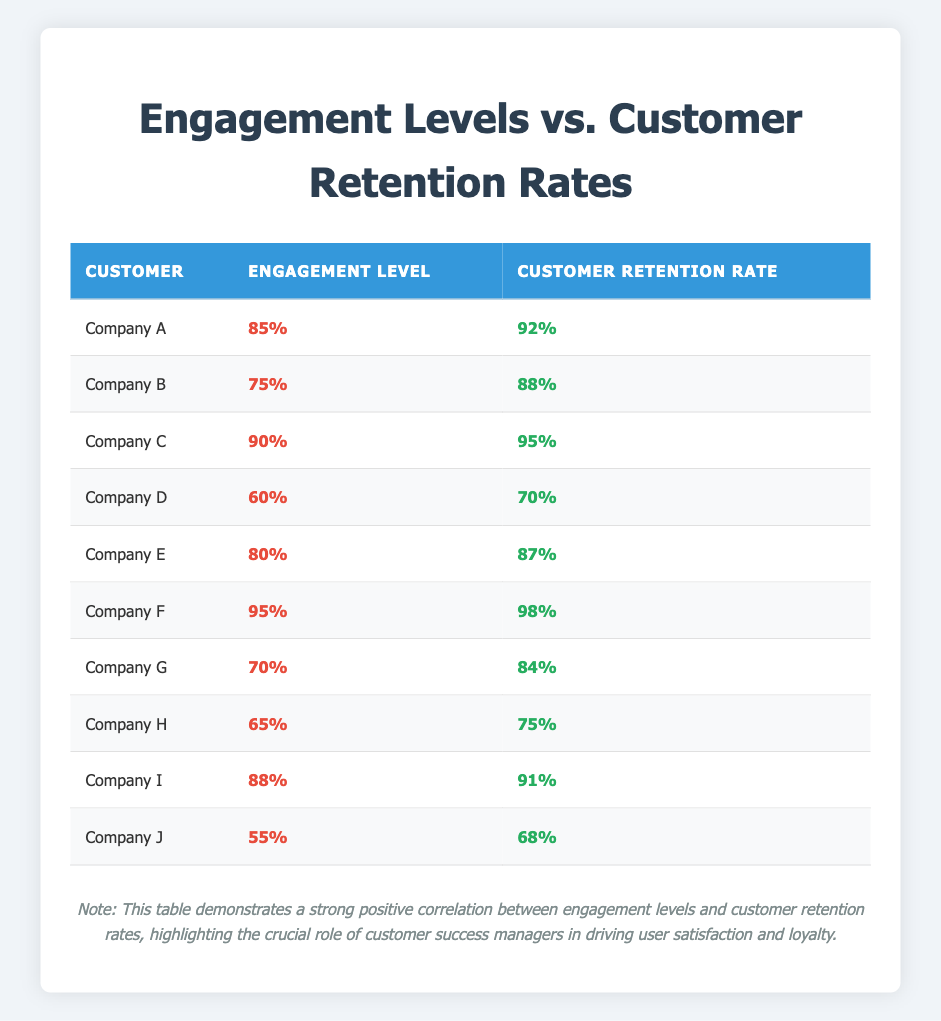What is the engagement level of Company A? Company A's engagement level is listed in the table, which shows it as 85%.
Answer: 85% Which company has the highest customer retention rate? By reviewing the customer retention rates in the table, Company F has the highest rate at 98%.
Answer: Company F What is the average engagement level of all companies? To find the average engagement level, add all engagement levels (85 + 75 + 90 + 60 + 80 + 95 + 70 + 65 + 88 + 55 =  88) and divide by the number of companies (10), resulting in an average engagement level of 78.
Answer: 78 Is the engagement level of Company J greater than 60? Company J's engagement level is 55, which is lower than 60, therefore this statement is false.
Answer: No How many companies have an engagement level greater than 80? Looking at the engagement levels, Companies A, C, E, and F have levels above 80, totaling 4 companies.
Answer: 4 What is the difference between the engagement level of Company C and Company D? The engagement levels are 90 for Company C and 60 for Company D. Calculating the difference gives us 90 - 60 = 30.
Answer: 30 Which companies have a retention rate of 90 or above? By reviewing the retention rates, Companies C, F, and I are identified as having rates of 95, 98, and 91 respectively.
Answer: Companies C, F, I What is the median customer retention rate? To find the median, we first list all retention rates in order: 68, 70, 75, 84, 87, 88, 91, 92, 95, 98. The median is the average of the 5th and 6th values (87 and 88), so (87 + 88) / 2 = 87.5.
Answer: 87.5 Is there a company with both the engagement level and customer retention rate below 70? Looking at the data, Company D has an engagement level of 60 and a retention rate of 70, which does not meet the criteria; however, Company J has engagement 55 and retention 68, making it true.
Answer: Yes 